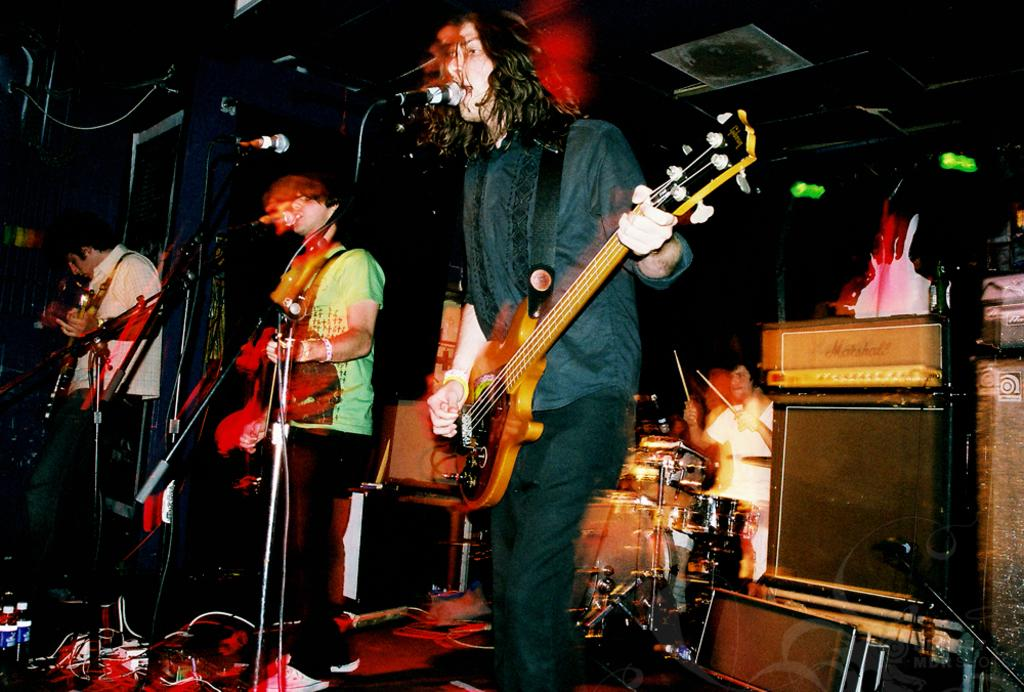How many people are in the image? There are three persons in the image. What are the persons doing in the image? The persons are in front of a microphone and playing guitars. What color is the light in the background of the image? There is a green color light in the background. What other musical instruments can be seen in the image besides guitars? There are musical instruments in the image, but the specific instruments are not mentioned in the facts provided. What type of grip does the quarter have on the school in the image? There is no quarter or school present in the image; it features three persons playing guitars in front of a microphone. 